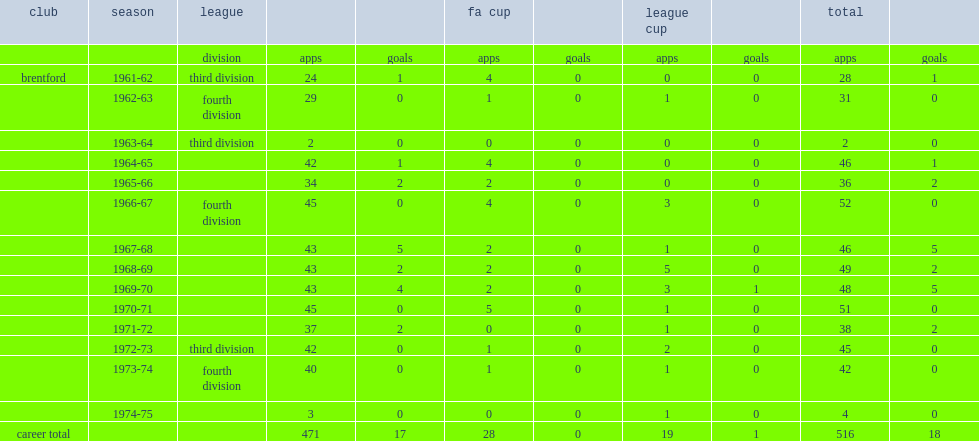What was the number of appearances made by peter gelson for brentford in all competitions? 516.0. 